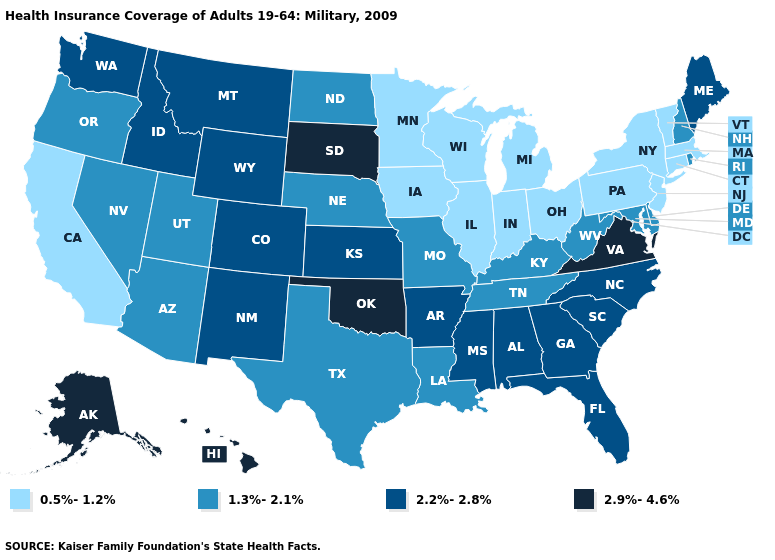Which states have the lowest value in the USA?
Be succinct. California, Connecticut, Illinois, Indiana, Iowa, Massachusetts, Michigan, Minnesota, New Jersey, New York, Ohio, Pennsylvania, Vermont, Wisconsin. What is the value of Nebraska?
Short answer required. 1.3%-2.1%. What is the value of New York?
Write a very short answer. 0.5%-1.2%. Does Maine have a lower value than Arizona?
Short answer required. No. Which states hav the highest value in the West?
Answer briefly. Alaska, Hawaii. Which states hav the highest value in the Northeast?
Write a very short answer. Maine. Which states have the lowest value in the USA?
Quick response, please. California, Connecticut, Illinois, Indiana, Iowa, Massachusetts, Michigan, Minnesota, New Jersey, New York, Ohio, Pennsylvania, Vermont, Wisconsin. Which states have the lowest value in the Northeast?
Answer briefly. Connecticut, Massachusetts, New Jersey, New York, Pennsylvania, Vermont. What is the value of California?
Short answer required. 0.5%-1.2%. What is the lowest value in the South?
Be succinct. 1.3%-2.1%. Does the first symbol in the legend represent the smallest category?
Be succinct. Yes. Which states hav the highest value in the West?
Short answer required. Alaska, Hawaii. Name the states that have a value in the range 2.9%-4.6%?
Give a very brief answer. Alaska, Hawaii, Oklahoma, South Dakota, Virginia. Name the states that have a value in the range 2.9%-4.6%?
Be succinct. Alaska, Hawaii, Oklahoma, South Dakota, Virginia. Name the states that have a value in the range 2.9%-4.6%?
Give a very brief answer. Alaska, Hawaii, Oklahoma, South Dakota, Virginia. 